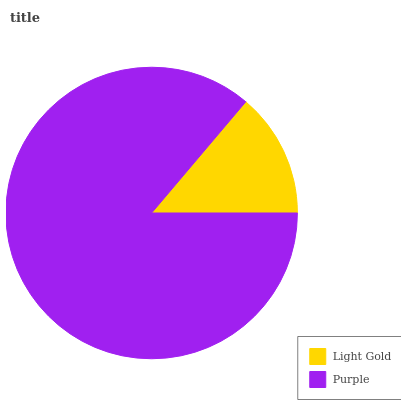Is Light Gold the minimum?
Answer yes or no. Yes. Is Purple the maximum?
Answer yes or no. Yes. Is Purple the minimum?
Answer yes or no. No. Is Purple greater than Light Gold?
Answer yes or no. Yes. Is Light Gold less than Purple?
Answer yes or no. Yes. Is Light Gold greater than Purple?
Answer yes or no. No. Is Purple less than Light Gold?
Answer yes or no. No. Is Purple the high median?
Answer yes or no. Yes. Is Light Gold the low median?
Answer yes or no. Yes. Is Light Gold the high median?
Answer yes or no. No. Is Purple the low median?
Answer yes or no. No. 